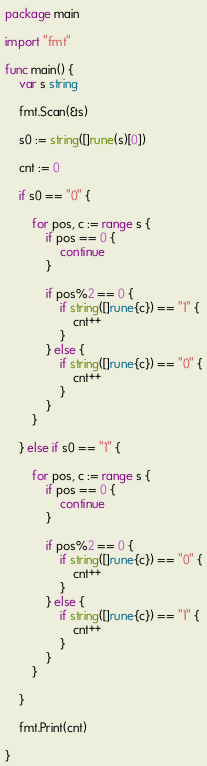Convert code to text. <code><loc_0><loc_0><loc_500><loc_500><_Go_>package main

import "fmt"

func main() {
	var s string

	fmt.Scan(&s)

	s0 := string([]rune(s)[0])

	cnt := 0

	if s0 == "0" {

		for pos, c := range s {
			if pos == 0 {
				continue
			}

			if pos%2 == 0 {
				if string([]rune{c}) == "1" {
					cnt++
				}
			} else {
				if string([]rune{c}) == "0" {
					cnt++
				}
			}
		}

	} else if s0 == "1" {

		for pos, c := range s {
			if pos == 0 {
				continue
			}

			if pos%2 == 0 {
				if string([]rune{c}) == "0" {
					cnt++
				}
			} else {
				if string([]rune{c}) == "1" {
					cnt++
				}
			}
		}

	}

	fmt.Print(cnt)

}
</code> 